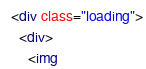Convert code to text. <code><loc_0><loc_0><loc_500><loc_500><_HTML_>  <div class="loading">
    <div>
      <img</code> 